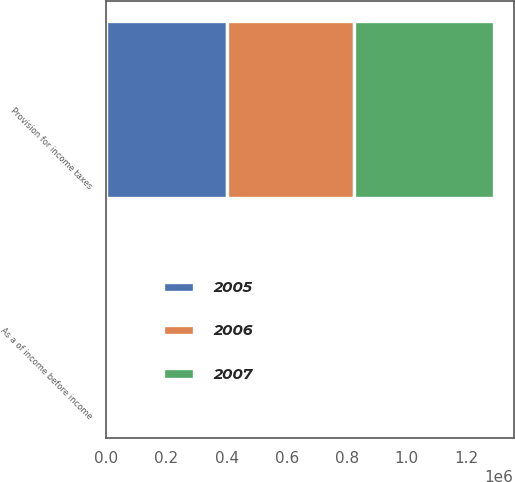Convert chart to OTSL. <chart><loc_0><loc_0><loc_500><loc_500><stacked_bar_chart><ecel><fcel>Provision for income taxes<fcel>As a of income before income<nl><fcel>2007<fcel>467285<fcel>30<nl><fcel>2006<fcel>421418<fcel>27<nl><fcel>2005<fcel>402600<fcel>54<nl></chart> 